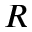Convert formula to latex. <formula><loc_0><loc_0><loc_500><loc_500>R</formula> 